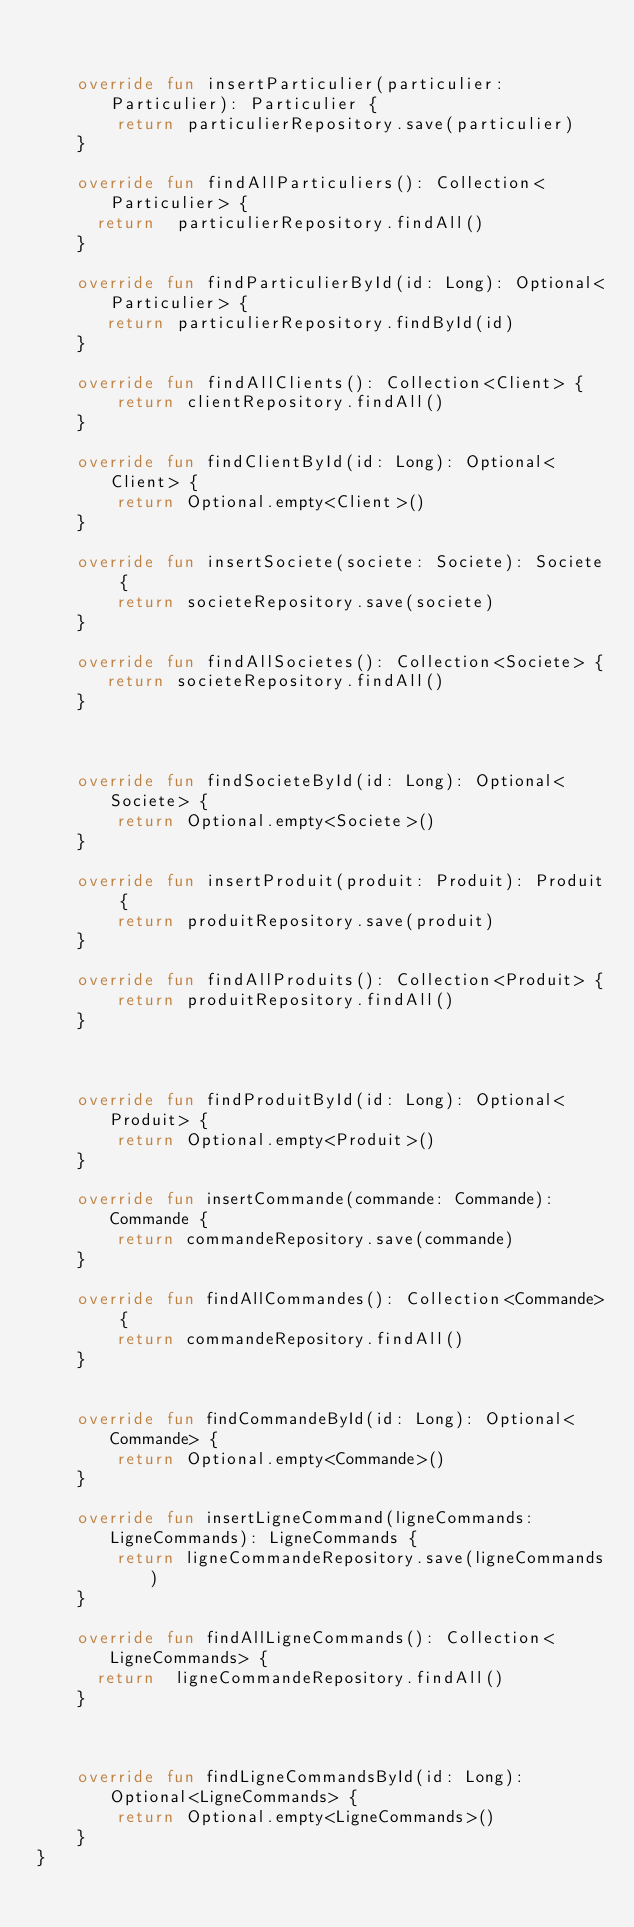Convert code to text. <code><loc_0><loc_0><loc_500><loc_500><_Kotlin_>

    override fun insertParticulier(particulier: Particulier): Particulier {
        return particulierRepository.save(particulier)
    }

    override fun findAllParticuliers(): Collection<Particulier> {
      return  particulierRepository.findAll()
    }

    override fun findParticulierById(id: Long): Optional<Particulier> {
       return particulierRepository.findById(id)
    }

    override fun findAllClients(): Collection<Client> {
        return clientRepository.findAll()
    }

    override fun findClientById(id: Long): Optional<Client> {
        return Optional.empty<Client>()
    }

    override fun insertSociete(societe: Societe): Societe {
        return societeRepository.save(societe)
    }

    override fun findAllSocietes(): Collection<Societe> {
       return societeRepository.findAll()
    }



    override fun findSocieteById(id: Long): Optional<Societe> {
        return Optional.empty<Societe>()
    }

    override fun insertProduit(produit: Produit): Produit {
        return produitRepository.save(produit)
    }

    override fun findAllProduits(): Collection<Produit> {
        return produitRepository.findAll()
    }



    override fun findProduitById(id: Long): Optional<Produit> {
        return Optional.empty<Produit>()
    }

    override fun insertCommande(commande: Commande): Commande {
        return commandeRepository.save(commande)
    }

    override fun findAllCommandes(): Collection<Commande> {
        return commandeRepository.findAll()
    }


    override fun findCommandeById(id: Long): Optional<Commande> {
        return Optional.empty<Commande>()
    }

    override fun insertLigneCommand(ligneCommands: LigneCommands): LigneCommands {
        return ligneCommandeRepository.save(ligneCommands)
    }

    override fun findAllLigneCommands(): Collection<LigneCommands> {
      return  ligneCommandeRepository.findAll()
    }



    override fun findLigneCommandsById(id: Long): Optional<LigneCommands> {
        return Optional.empty<LigneCommands>()
    }
}</code> 